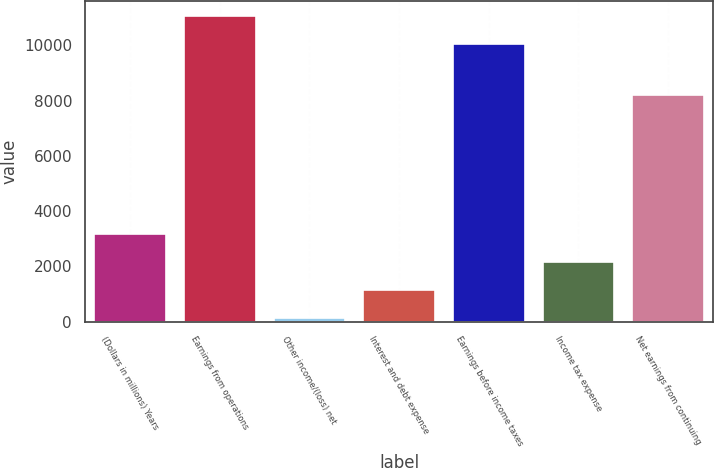Convert chart to OTSL. <chart><loc_0><loc_0><loc_500><loc_500><bar_chart><fcel>(Dollars in millions) Years<fcel>Earnings from operations<fcel>Other income/(loss) net<fcel>Interest and debt expense<fcel>Earnings before income taxes<fcel>Income tax expense<fcel>Net earnings from continuing<nl><fcel>3173.7<fcel>11061.9<fcel>129<fcel>1143.9<fcel>10047<fcel>2158.8<fcel>8197<nl></chart> 